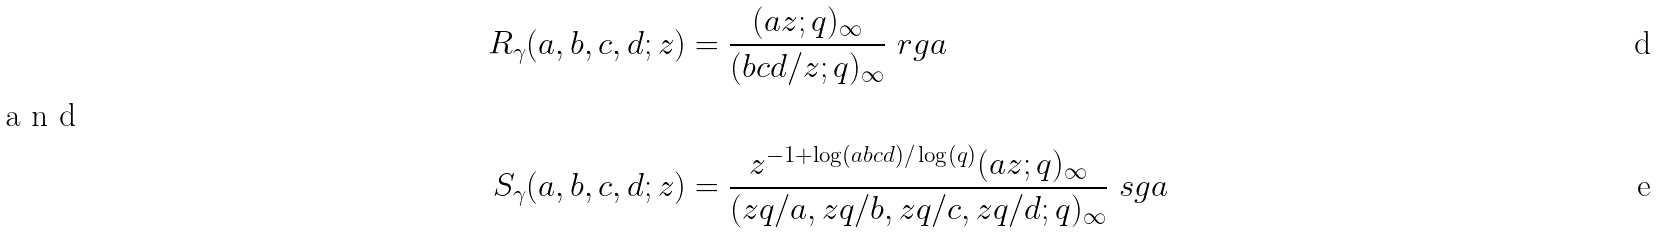Convert formula to latex. <formula><loc_0><loc_0><loc_500><loc_500>R _ { \gamma } ( a , b , c , d ; z ) & = \frac { ( a z ; q ) _ { \infty } } { ( b c d / z ; q ) _ { \infty } } \ r g a \\ \intertext { a n d } S _ { \gamma } ( a , b , c , d ; z ) & = \frac { z ^ { - 1 + \log ( a b c d ) / \log ( q ) } ( a z ; q ) _ { \infty } } { ( z q / a , z q / b , z q / c , z q / d ; q ) _ { \infty } } \ s g a</formula> 